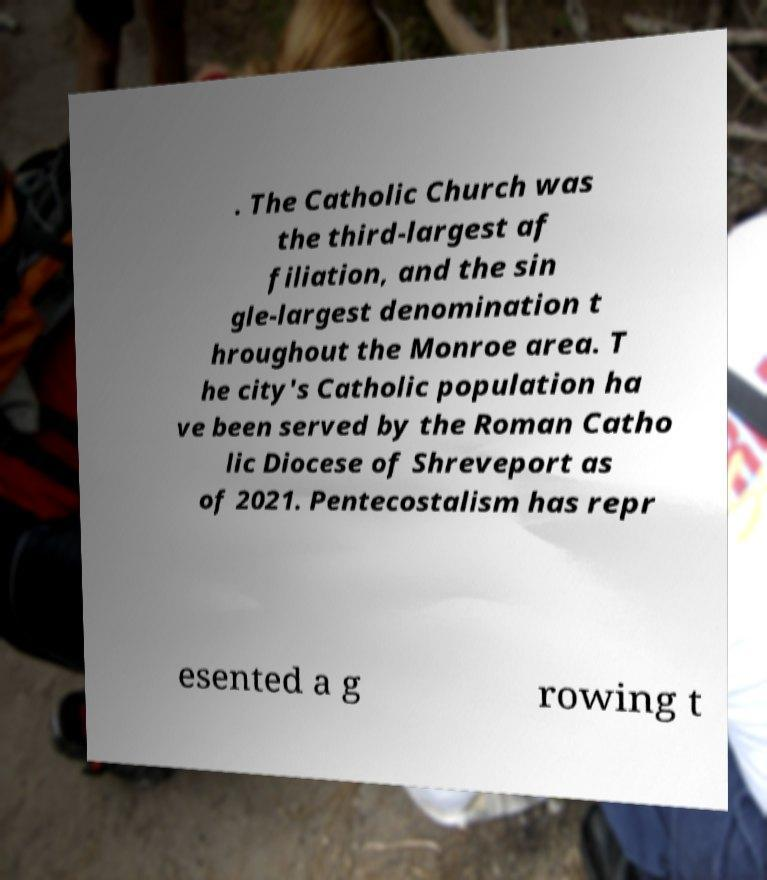Please read and relay the text visible in this image. What does it say? . The Catholic Church was the third-largest af filiation, and the sin gle-largest denomination t hroughout the Monroe area. T he city's Catholic population ha ve been served by the Roman Catho lic Diocese of Shreveport as of 2021. Pentecostalism has repr esented a g rowing t 